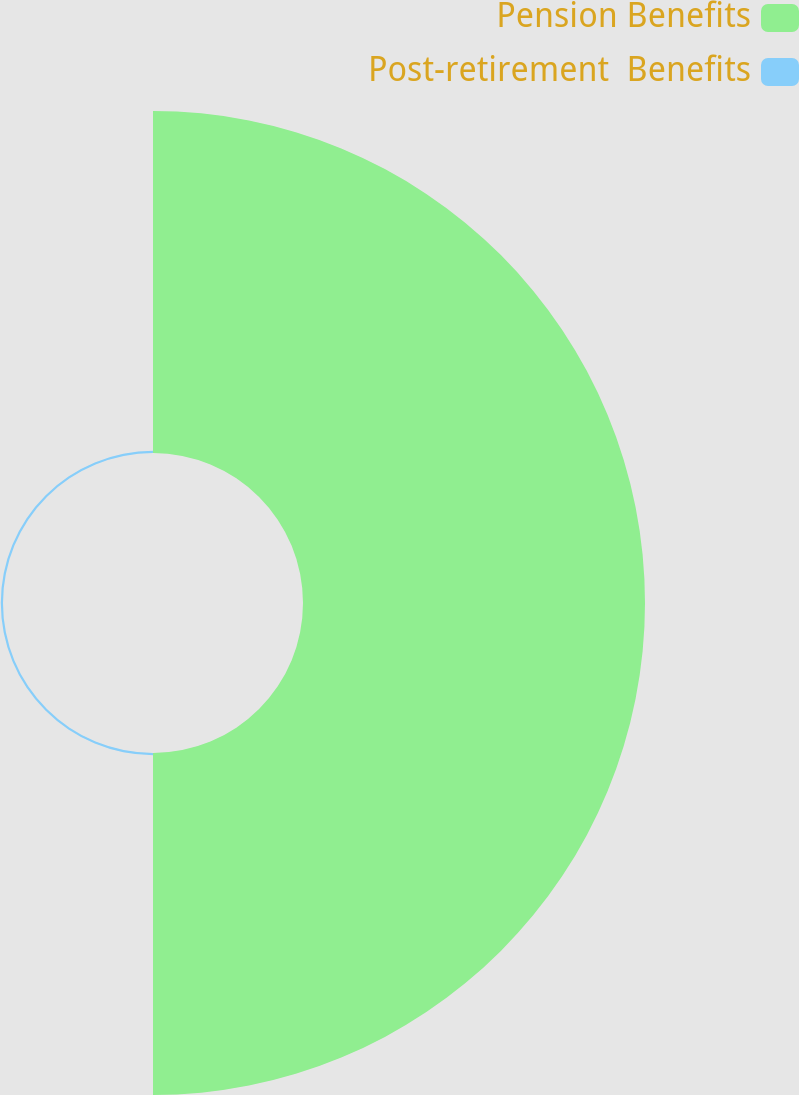Convert chart to OTSL. <chart><loc_0><loc_0><loc_500><loc_500><pie_chart><fcel>Pension Benefits<fcel>Post-retirement  Benefits<nl><fcel>99.36%<fcel>0.64%<nl></chart> 